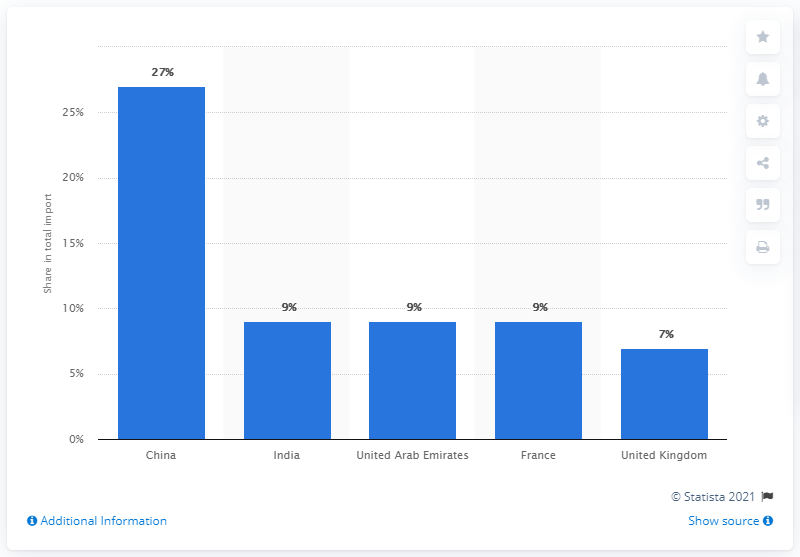List a handful of essential elements in this visual. In 2019, China was Ethiopia's most important import partner. 